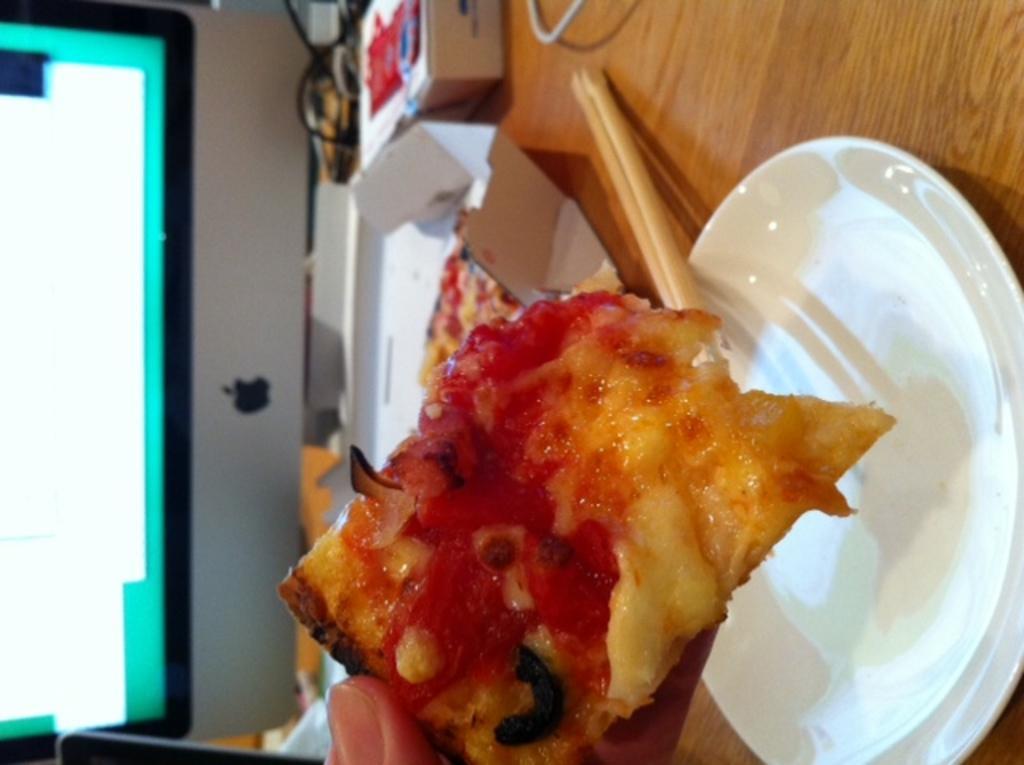How would you summarize this image in a sentence or two? In this image we can see a table on which a plate and food item is there and a monitor is there. 